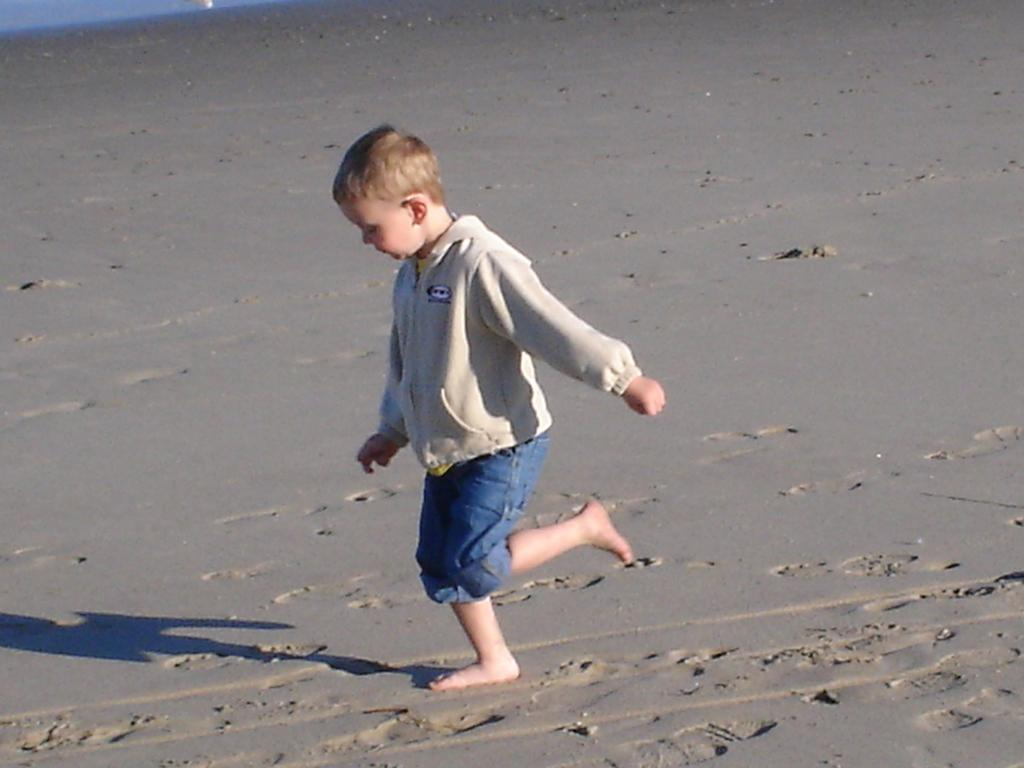What is the boy doing in the image? The boy is walking on wet sand in the image. What can be seen in the top left side corner of the image? There is a white object and a blue object in the top left side corner of the image. What type of development can be seen in the background of the image? There is no development visible in the background of the image; it only shows the boy walking on wet sand and the objects in the top left side corner. 